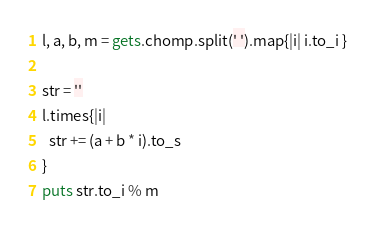Convert code to text. <code><loc_0><loc_0><loc_500><loc_500><_Ruby_>l, a, b, m = gets.chomp.split(' ').map{|i| i.to_i }

str = ''
l.times{|i|
  str += (a + b * i).to_s
}
puts str.to_i % m
</code> 